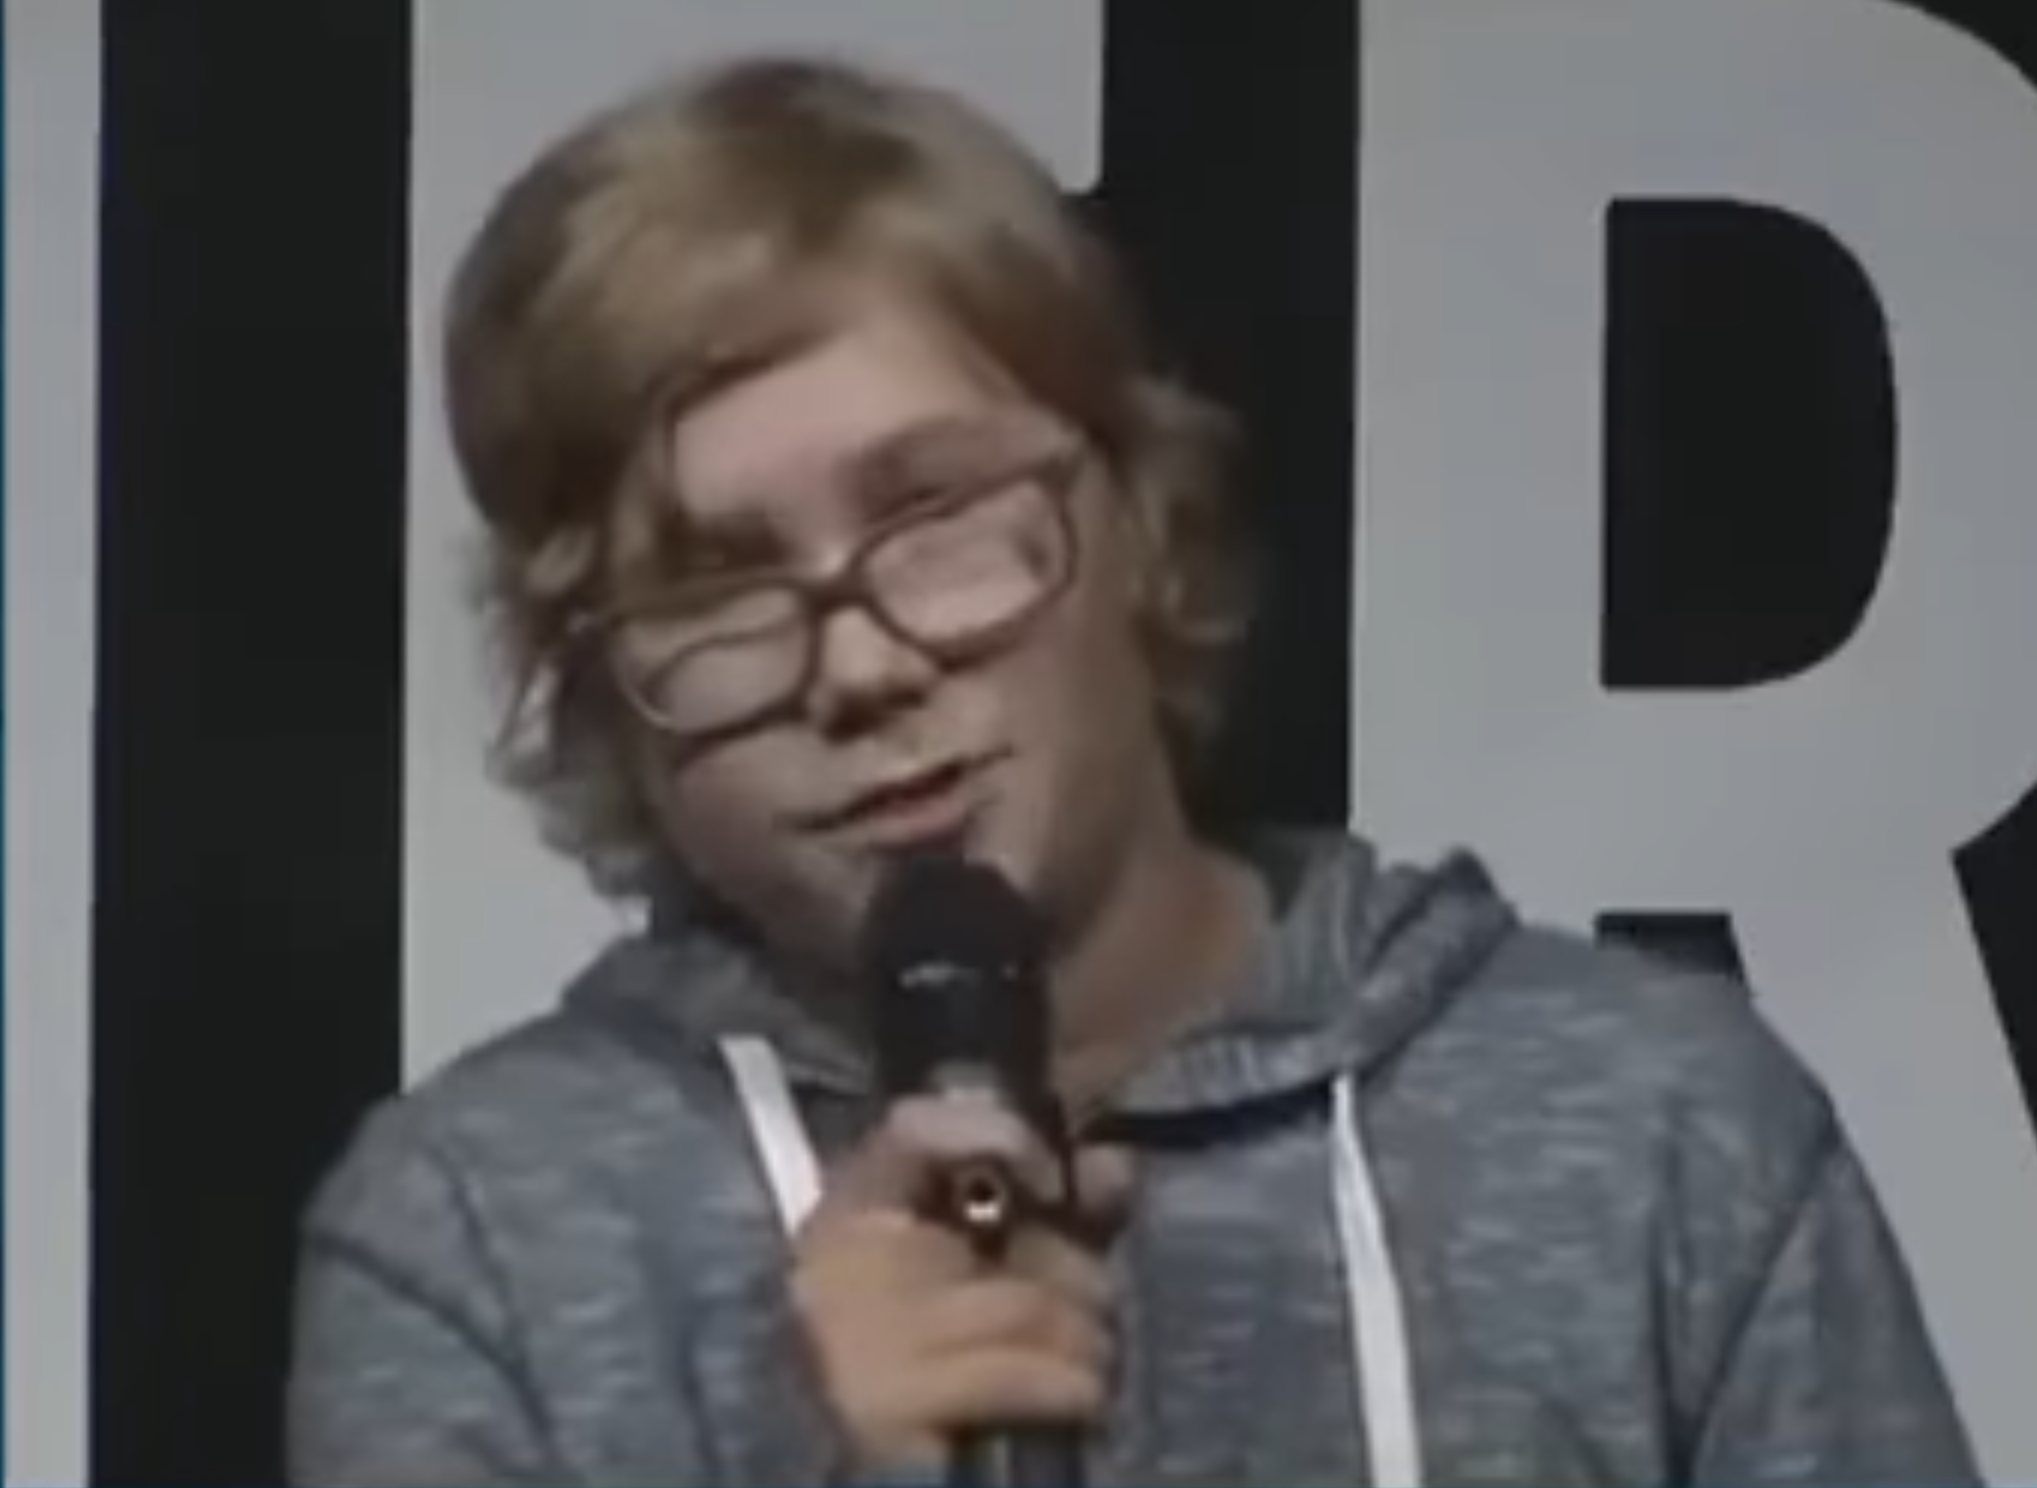descripe the image and make a prompt that creates a similar image The image shows a young person with blond hair and glasses speaking into a microphone. The person is wearing a gray sweatshirt. The background is black with a white R.

Prompt: A young person with blond hair and glasses is speaking into a microphone. The person is wearing a gray sweatshirt. The background is black with a white R. The person is speaking passionately about a topic they are knowledgeable about. They are using hand gestures to emphasize their points. The audience is engaged and listening attentively. 